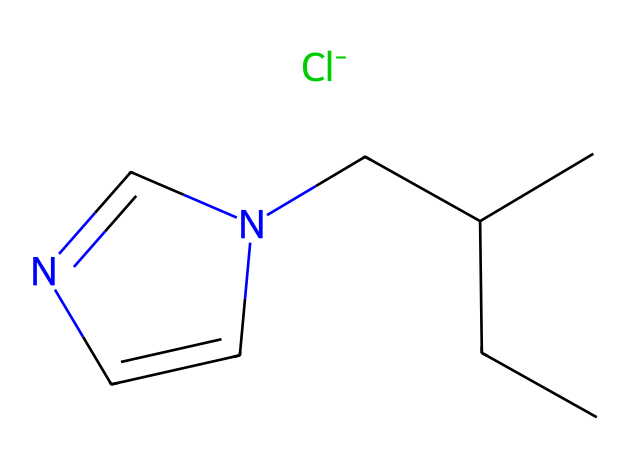what is the molecular formula of this ionic liquid? The SMILES representation allows us to deduce the molecular formula by identifying the constituent atoms. Counting the atoms from the structure, we find 10 carbon atoms, 15 hydrogen atoms, 2 nitrogen atoms, and 1 chlorine atom, which gives us the molecular formula C10H15ClN2.
Answer: C10H15ClN2 how many nitrogen atoms are present in the chemical structure? By analyzing the SMILES, we can see there are two nitrogen atoms in the structure, as indicated by the two 'N' letters.
Answer: 2 what type of ion is represented by Cl- in this ionic liquid? The 'Cl-' in the SMILES notation represents a chloride ion, which is a negatively charged ion or anion. This is a common component of ionic liquids.
Answer: anion what property makes this compound an ionic liquid? Ionic liquids are characterized by their low melting points and their ability to exist as liquid at room temperature. This compound exhibits these properties due to the presence of the ionic pair formed by the organic cation and chloride anion.
Answer: low melting point how does the structure of this ionic liquid aid in extracting genetic material? The positively charged portion of the compound can interact with negatively charged DNA, promoting solubility and extraction. This specific ionic structure may enhance the efficiency of extracting genetic material from ancient remains.
Answer: promotes solubility what is the role of the nitrogen atoms in the ionic liquid's structure? The nitrogen atoms play a vital role in stabilizing the ionic charge and providing solubility properties to the ionic liquid, facilitating the extraction process while stabilizing the ionic pair.
Answer: stabilizing ionic charge 